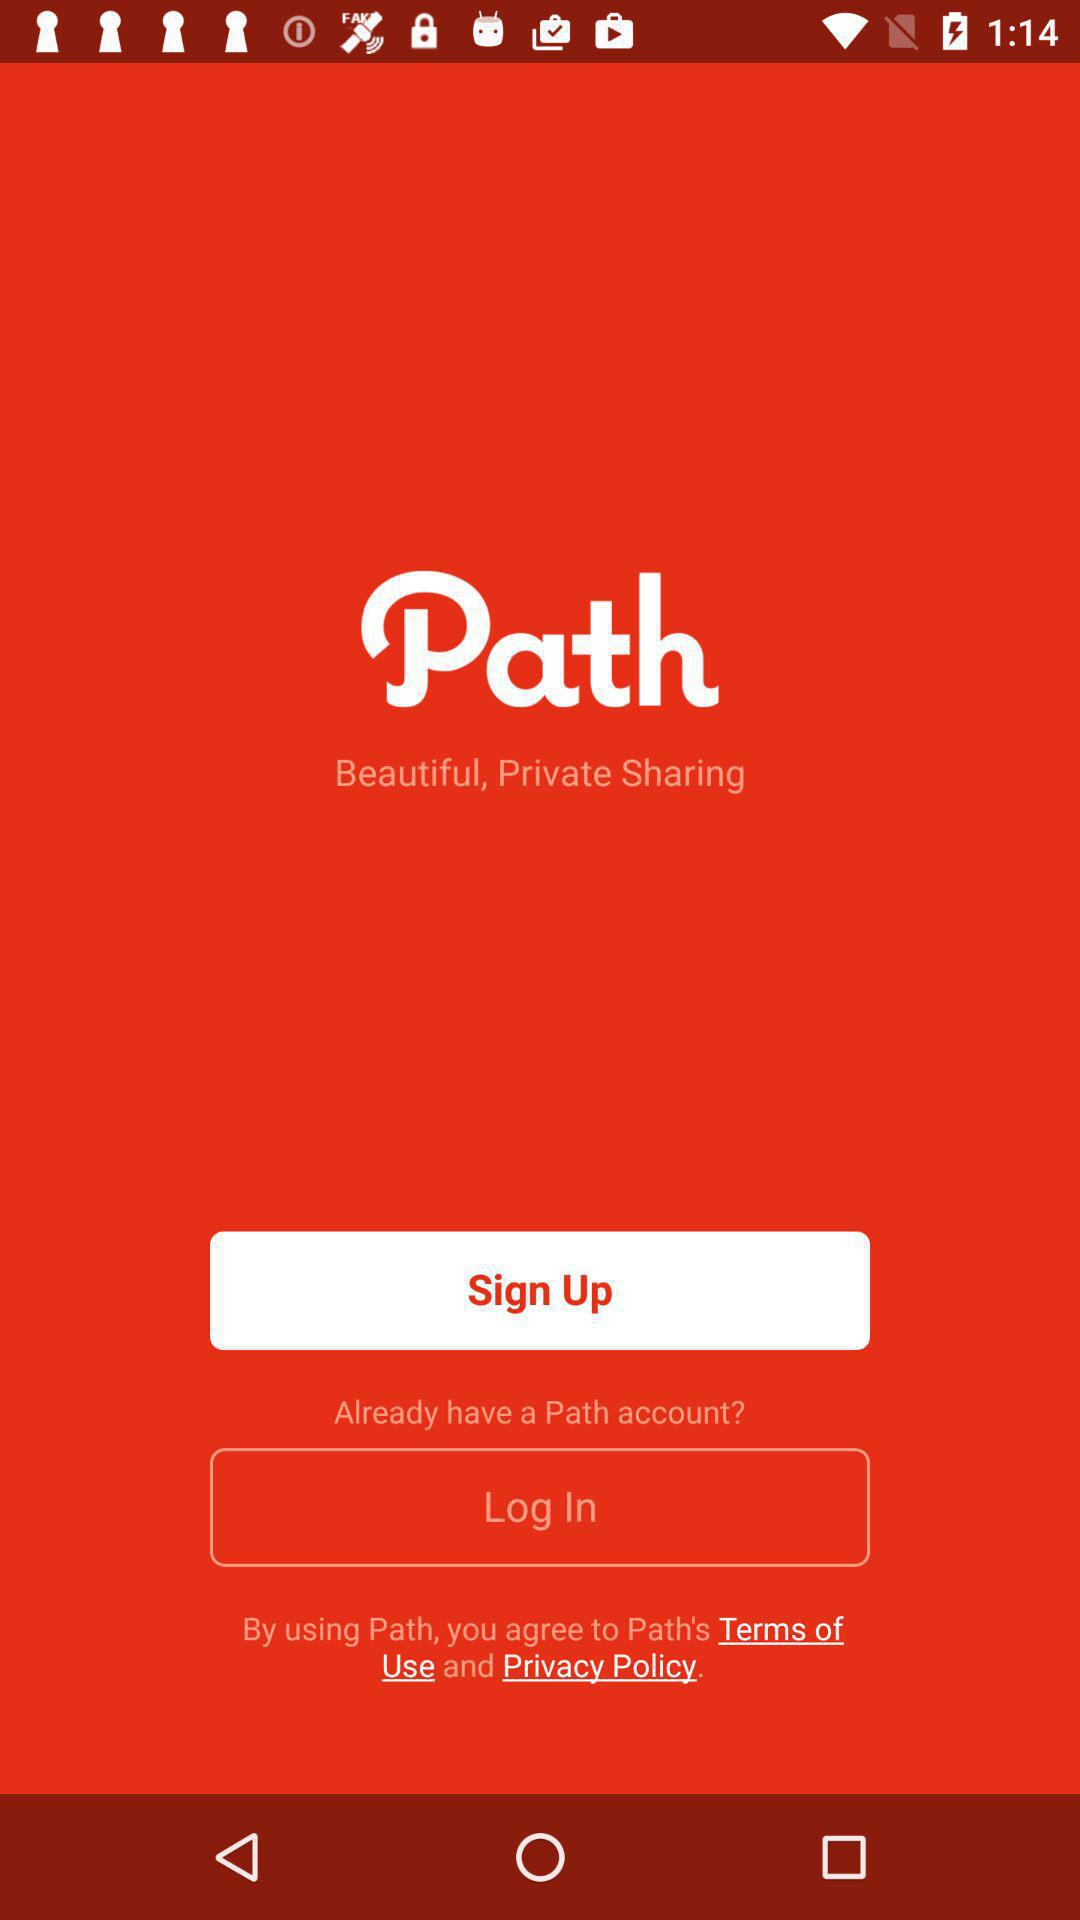What is the application name? The application name is "Path". 